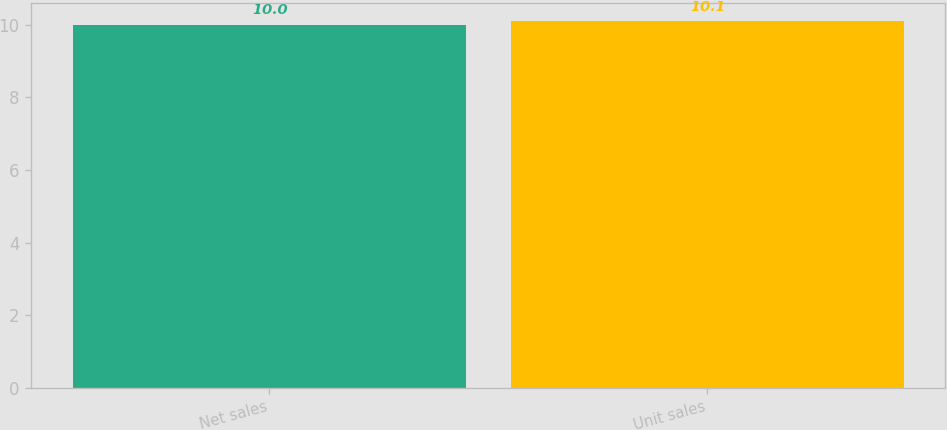<chart> <loc_0><loc_0><loc_500><loc_500><bar_chart><fcel>Net sales<fcel>Unit sales<nl><fcel>10<fcel>10.1<nl></chart> 